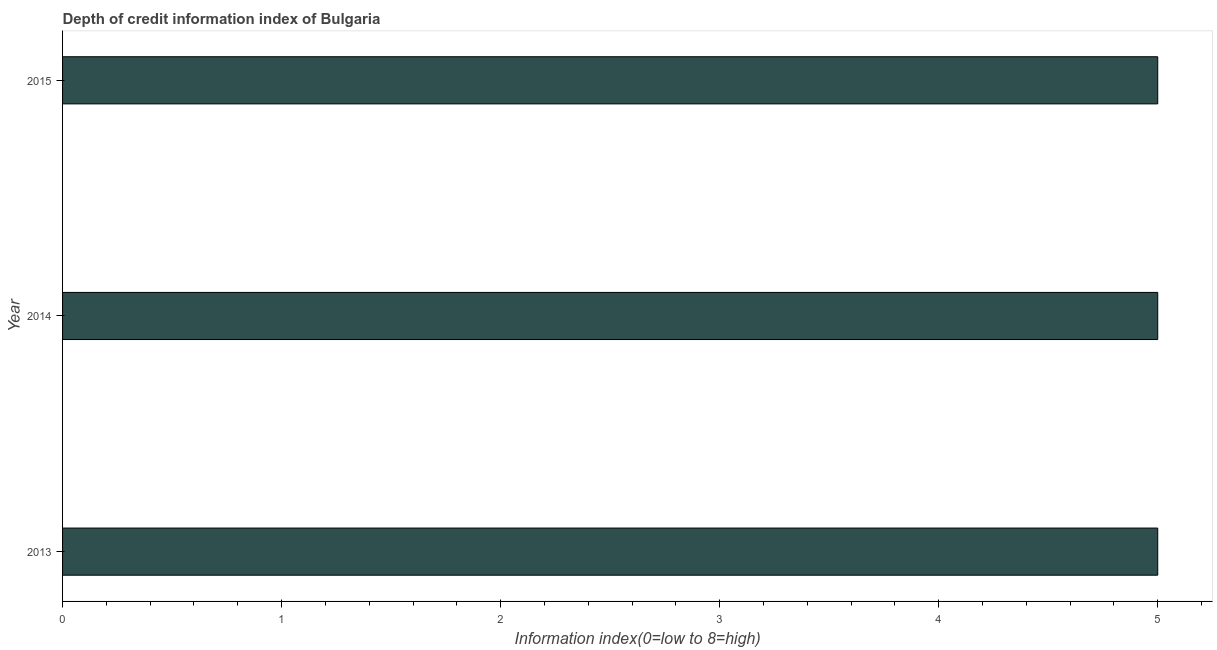Does the graph contain any zero values?
Offer a terse response. No. Does the graph contain grids?
Make the answer very short. No. What is the title of the graph?
Give a very brief answer. Depth of credit information index of Bulgaria. What is the label or title of the X-axis?
Provide a succinct answer. Information index(0=low to 8=high). What is the label or title of the Y-axis?
Your answer should be compact. Year. What is the depth of credit information index in 2014?
Ensure brevity in your answer.  5. Across all years, what is the maximum depth of credit information index?
Your answer should be very brief. 5. Across all years, what is the minimum depth of credit information index?
Provide a succinct answer. 5. In which year was the depth of credit information index maximum?
Keep it short and to the point. 2013. What is the sum of the depth of credit information index?
Offer a very short reply. 15. What is the median depth of credit information index?
Provide a succinct answer. 5. In how many years, is the depth of credit information index greater than 1.2 ?
Offer a very short reply. 3. What is the ratio of the depth of credit information index in 2013 to that in 2014?
Ensure brevity in your answer.  1. Is the depth of credit information index in 2013 less than that in 2015?
Keep it short and to the point. No. Is the difference between the depth of credit information index in 2013 and 2014 greater than the difference between any two years?
Make the answer very short. Yes. What is the difference between the highest and the lowest depth of credit information index?
Your answer should be very brief. 0. Are all the bars in the graph horizontal?
Offer a very short reply. Yes. How many years are there in the graph?
Offer a terse response. 3. What is the Information index(0=low to 8=high) in 2014?
Give a very brief answer. 5. What is the Information index(0=low to 8=high) in 2015?
Offer a very short reply. 5. What is the difference between the Information index(0=low to 8=high) in 2014 and 2015?
Your response must be concise. 0. What is the ratio of the Information index(0=low to 8=high) in 2013 to that in 2014?
Give a very brief answer. 1. 